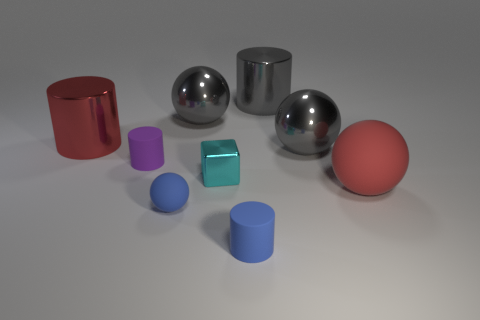Does the red metallic object have the same shape as the small purple object?
Give a very brief answer. Yes. What number of other things are there of the same size as the gray cylinder?
Offer a very short reply. 4. The big rubber sphere is what color?
Give a very brief answer. Red. How many small objects are purple cylinders or cyan cubes?
Make the answer very short. 2. Is the size of the matte cylinder behind the small cyan block the same as the cylinder in front of the red ball?
Offer a terse response. Yes. What is the size of the gray shiny object that is the same shape as the small purple object?
Your answer should be very brief. Large. Is the number of large red shiny cylinders that are in front of the large red matte object greater than the number of rubber objects that are left of the block?
Make the answer very short. No. What is the material of the cylinder that is behind the blue rubber ball and in front of the large red cylinder?
Give a very brief answer. Rubber. There is a tiny thing that is the same shape as the big red matte thing; what color is it?
Offer a terse response. Blue. The cyan object is what size?
Make the answer very short. Small. 